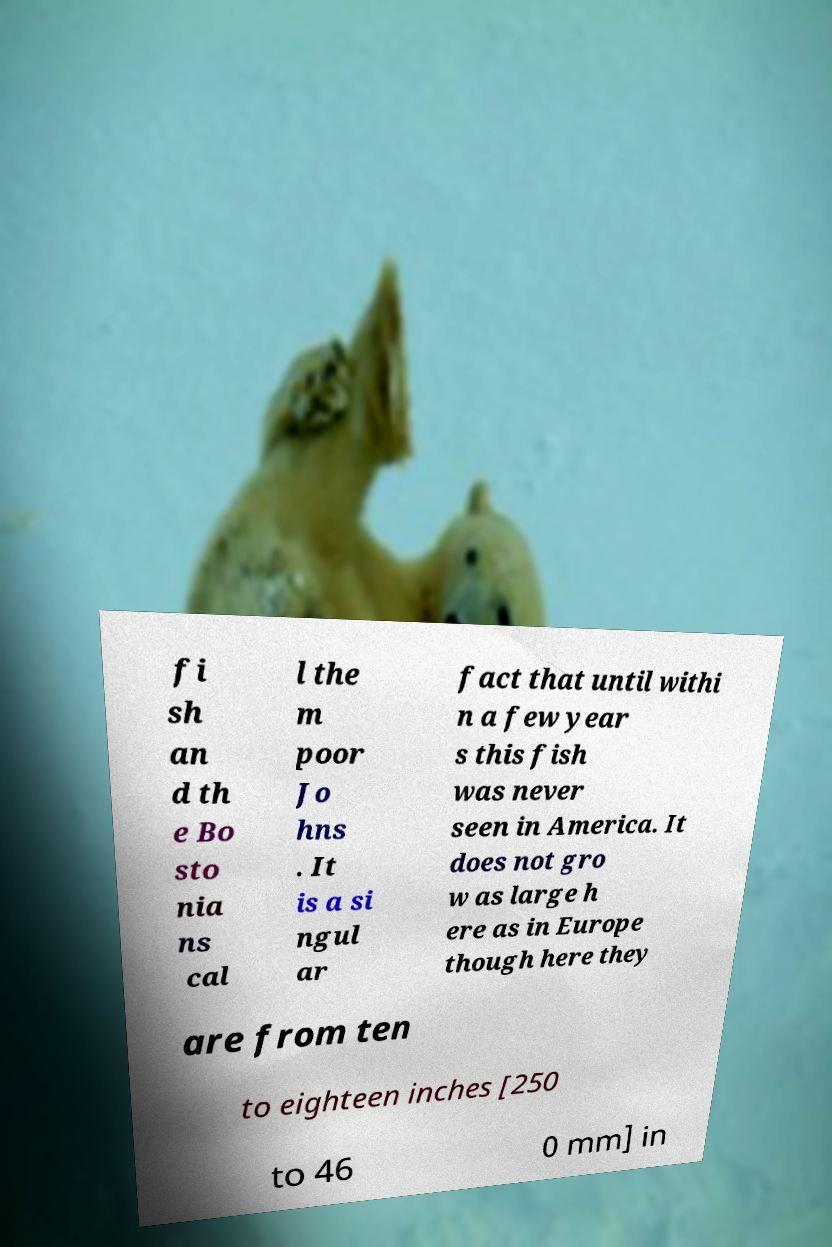I need the written content from this picture converted into text. Can you do that? fi sh an d th e Bo sto nia ns cal l the m poor Jo hns . It is a si ngul ar fact that until withi n a few year s this fish was never seen in America. It does not gro w as large h ere as in Europe though here they are from ten to eighteen inches [250 to 46 0 mm] in 